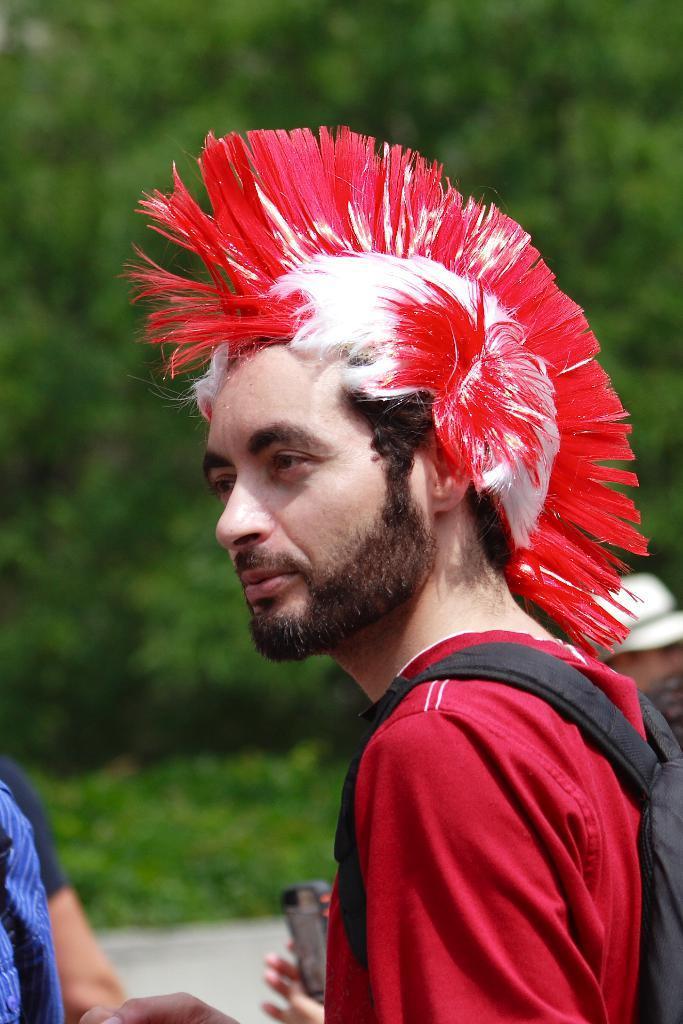Describe this image in one or two sentences. In this image there is a person on the left corner. There are people on the right corner. We can see a person wearing the bag. And there are trees in the background. 